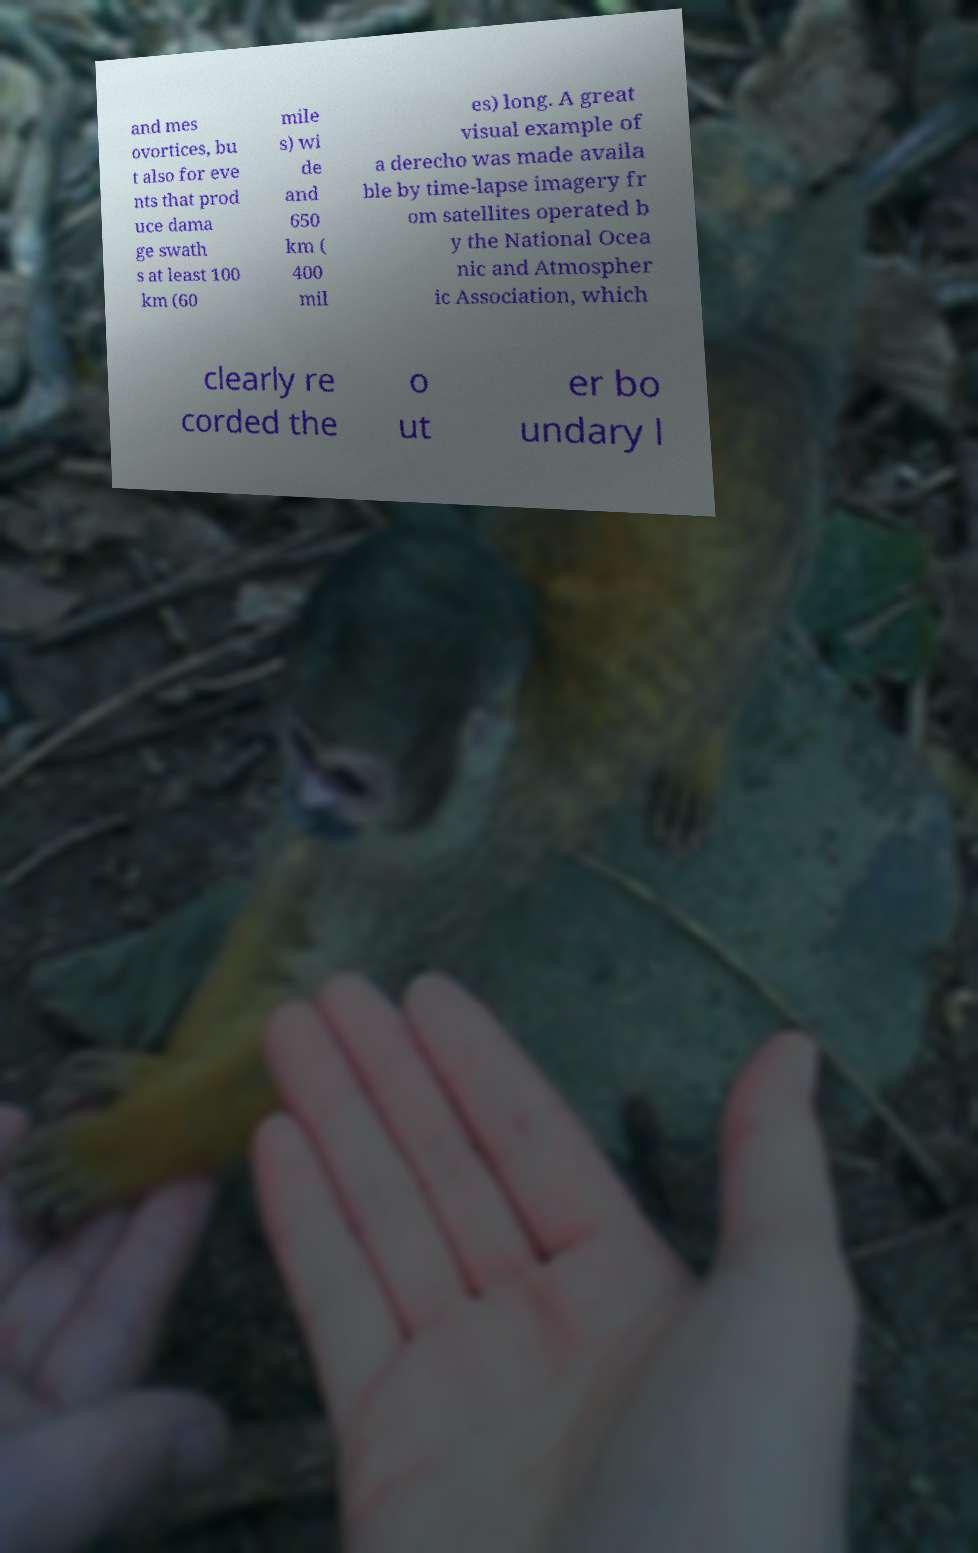What messages or text are displayed in this image? I need them in a readable, typed format. and mes ovortices, bu t also for eve nts that prod uce dama ge swath s at least 100 km (60 mile s) wi de and 650 km ( 400 mil es) long. A great visual example of a derecho was made availa ble by time-lapse imagery fr om satellites operated b y the National Ocea nic and Atmospher ic Association, which clearly re corded the o ut er bo undary l 